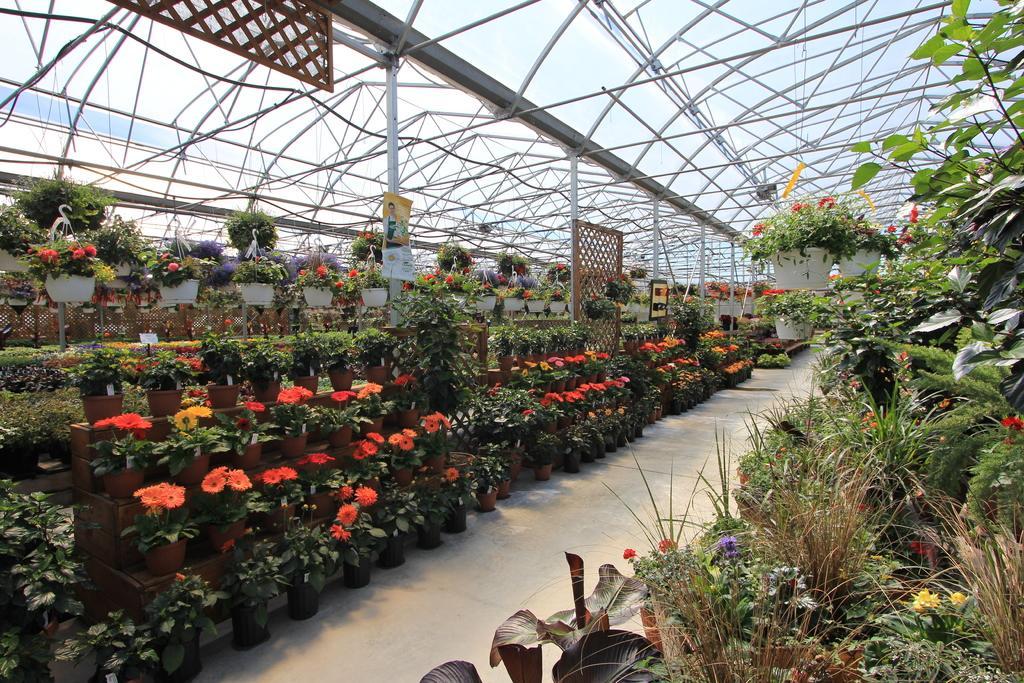How would you summarize this image in a sentence or two? In this image there are flower pot plants, mesh, rods, posters and objects. 